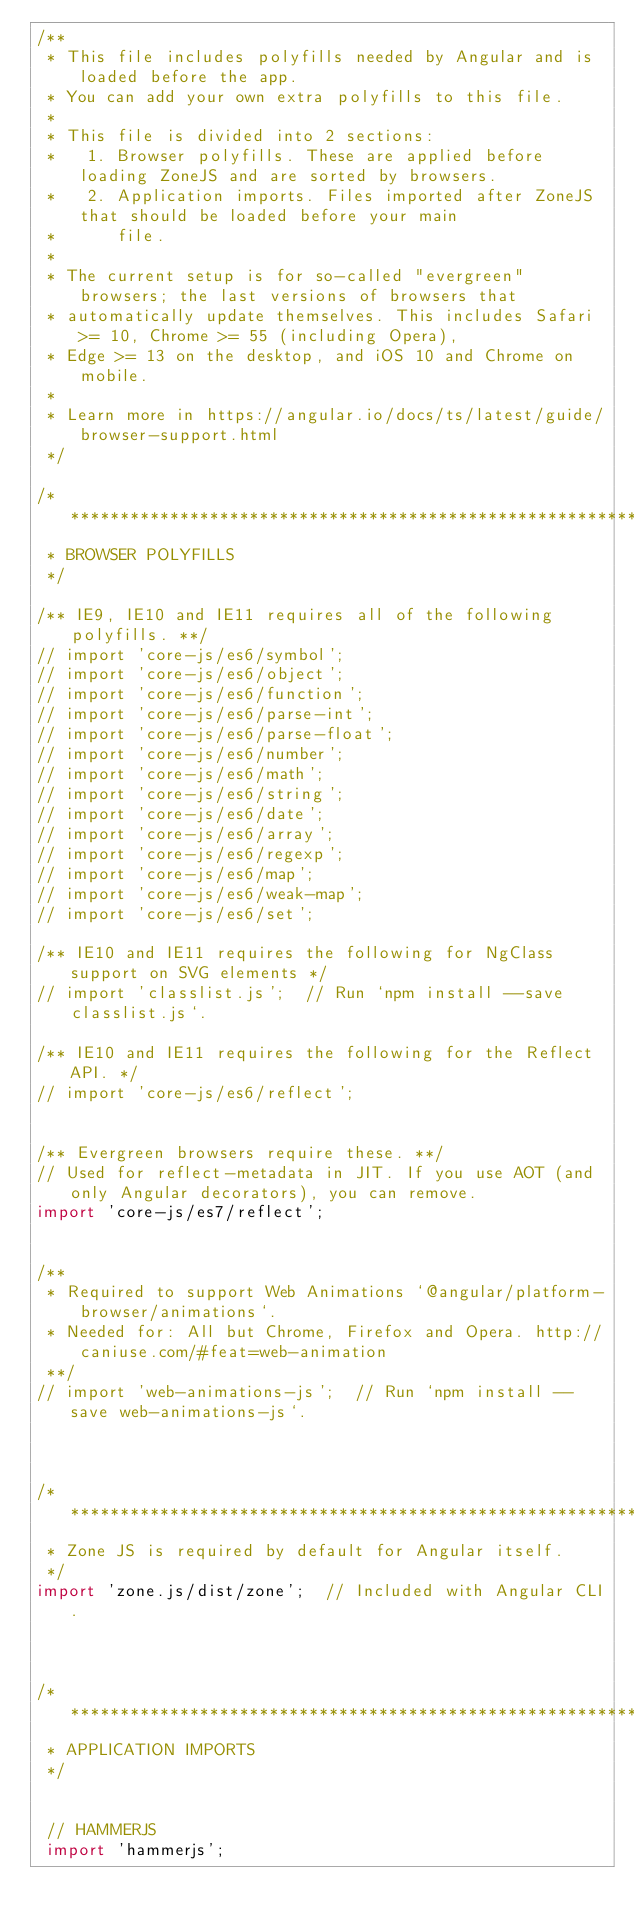<code> <loc_0><loc_0><loc_500><loc_500><_TypeScript_>/**
 * This file includes polyfills needed by Angular and is loaded before the app.
 * You can add your own extra polyfills to this file.
 *
 * This file is divided into 2 sections:
 *   1. Browser polyfills. These are applied before loading ZoneJS and are sorted by browsers.
 *   2. Application imports. Files imported after ZoneJS that should be loaded before your main
 *      file.
 *
 * The current setup is for so-called "evergreen" browsers; the last versions of browsers that
 * automatically update themselves. This includes Safari >= 10, Chrome >= 55 (including Opera),
 * Edge >= 13 on the desktop, and iOS 10 and Chrome on mobile.
 *
 * Learn more in https://angular.io/docs/ts/latest/guide/browser-support.html
 */

/***************************************************************************************************
 * BROWSER POLYFILLS
 */

/** IE9, IE10 and IE11 requires all of the following polyfills. **/
// import 'core-js/es6/symbol';
// import 'core-js/es6/object';
// import 'core-js/es6/function';
// import 'core-js/es6/parse-int';
// import 'core-js/es6/parse-float';
// import 'core-js/es6/number';
// import 'core-js/es6/math';
// import 'core-js/es6/string';
// import 'core-js/es6/date';
// import 'core-js/es6/array';
// import 'core-js/es6/regexp';
// import 'core-js/es6/map';
// import 'core-js/es6/weak-map';
// import 'core-js/es6/set';

/** IE10 and IE11 requires the following for NgClass support on SVG elements */
// import 'classlist.js';  // Run `npm install --save classlist.js`.

/** IE10 and IE11 requires the following for the Reflect API. */
// import 'core-js/es6/reflect';


/** Evergreen browsers require these. **/
// Used for reflect-metadata in JIT. If you use AOT (and only Angular decorators), you can remove.
import 'core-js/es7/reflect';


/**
 * Required to support Web Animations `@angular/platform-browser/animations`.
 * Needed for: All but Chrome, Firefox and Opera. http://caniuse.com/#feat=web-animation
 **/
// import 'web-animations-js';  // Run `npm install --save web-animations-js`.



/***************************************************************************************************
 * Zone JS is required by default for Angular itself.
 */
import 'zone.js/dist/zone';  // Included with Angular CLI.



/***************************************************************************************************
 * APPLICATION IMPORTS
 */


 // HAMMERJS
 import 'hammerjs';</code> 